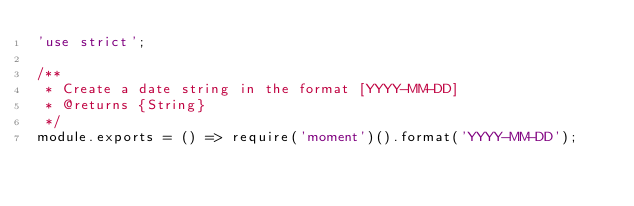Convert code to text. <code><loc_0><loc_0><loc_500><loc_500><_JavaScript_>'use strict';

/**
 * Create a date string in the format [YYYY-MM-DD]
 * @returns {String}
 */
module.exports = () => require('moment')().format('YYYY-MM-DD');
</code> 